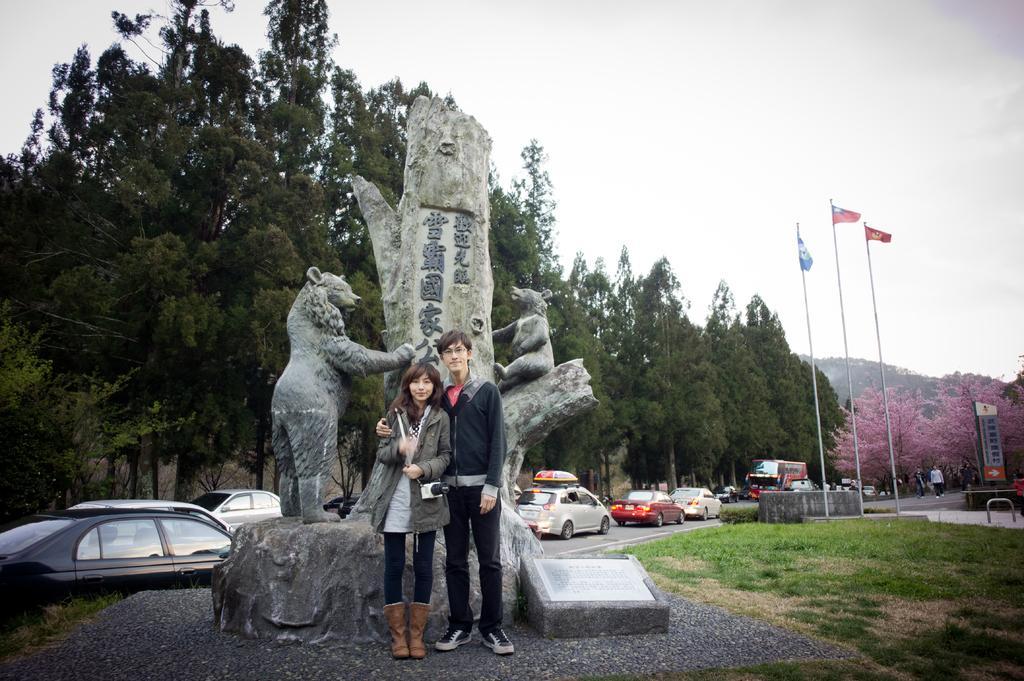Can you describe this image briefly? In the picture I can see a woman and a man standing here. In the background, I can see the statue, I can see memorial stone, vehicles moving on the road, I can see flags, trees, grass, boards and the sky in the background. 